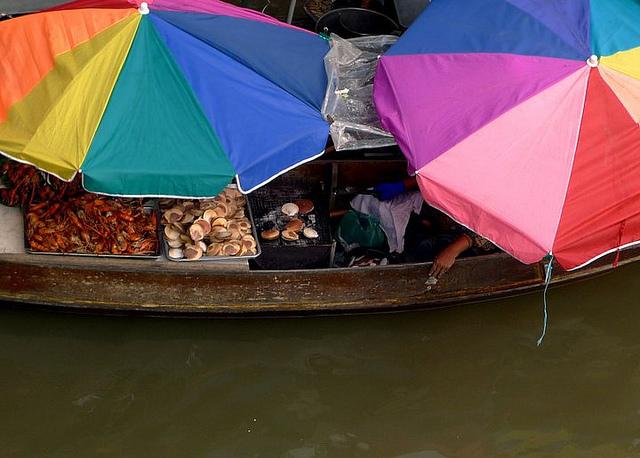How many umbrellas are there?
Be succinct. 2. Are there people here?
Keep it brief. Yes. Is there food in the picture?
Write a very short answer. Yes. What piece of clothing can be seen beneath the umbrella?
Keep it brief. Shirt. 